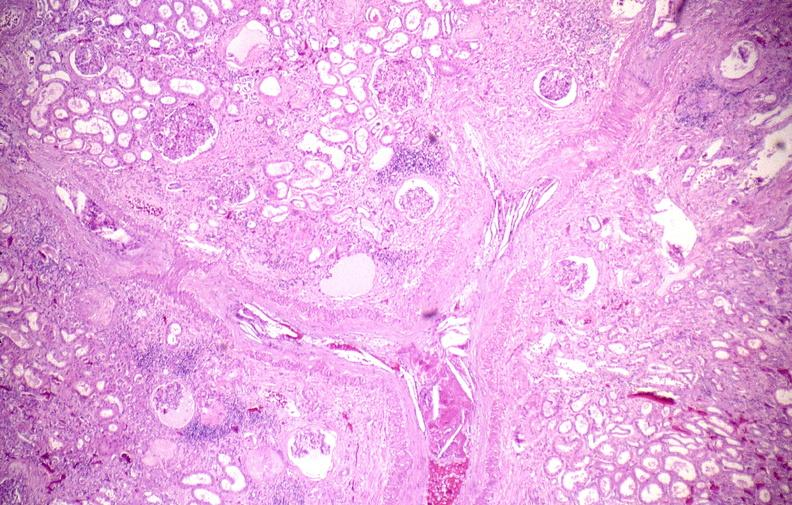what does this image show?
Answer the question using a single word or phrase. Atherosclerotic emboli 